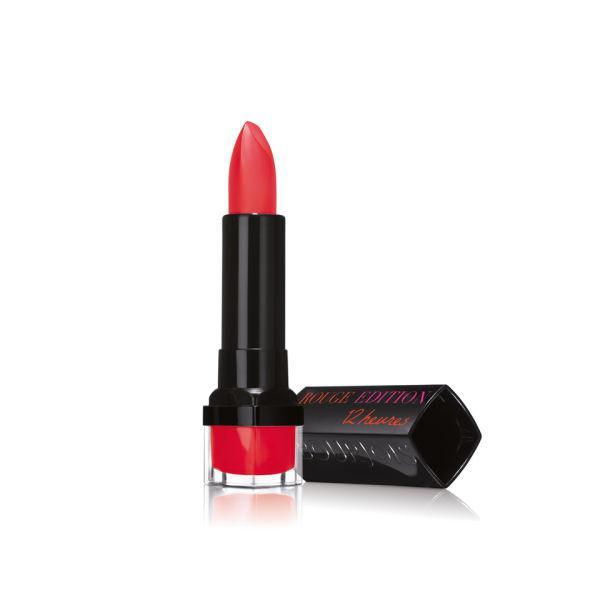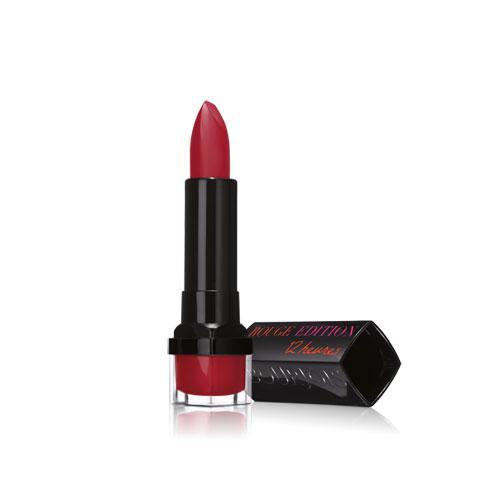The first image is the image on the left, the second image is the image on the right. Evaluate the accuracy of this statement regarding the images: "Images show a total of two red lipsticks with black caps.". Is it true? Answer yes or no. Yes. The first image is the image on the left, the second image is the image on the right. Analyze the images presented: Is the assertion "Two lipsticks with the color extended stand beside the black cap of each tube." valid? Answer yes or no. Yes. 